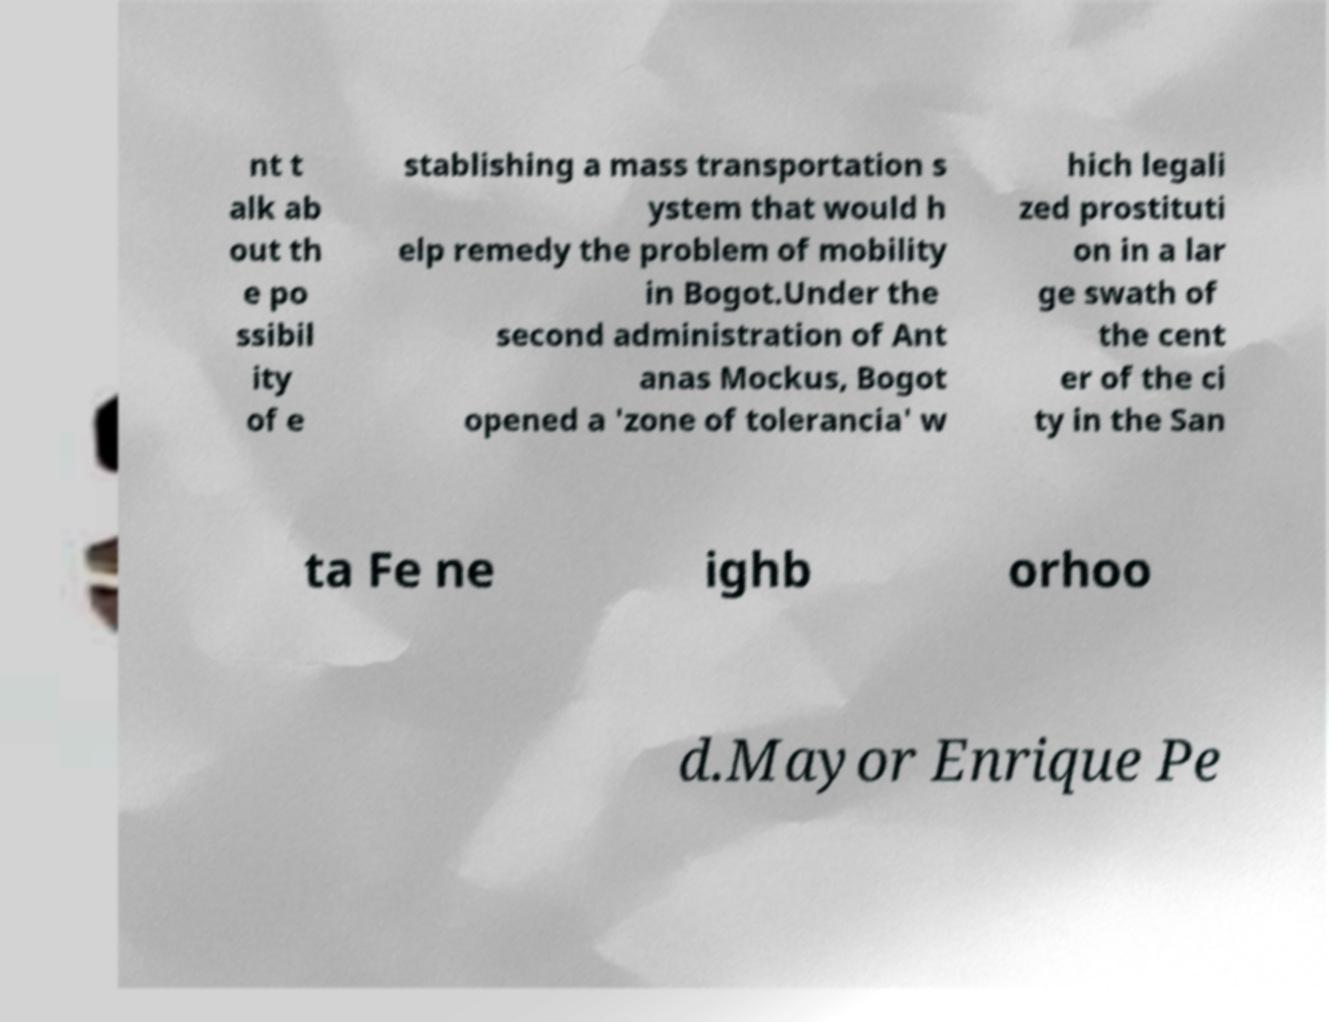Please read and relay the text visible in this image. What does it say? nt t alk ab out th e po ssibil ity of e stablishing a mass transportation s ystem that would h elp remedy the problem of mobility in Bogot.Under the second administration of Ant anas Mockus, Bogot opened a 'zone of tolerancia' w hich legali zed prostituti on in a lar ge swath of the cent er of the ci ty in the San ta Fe ne ighb orhoo d.Mayor Enrique Pe 